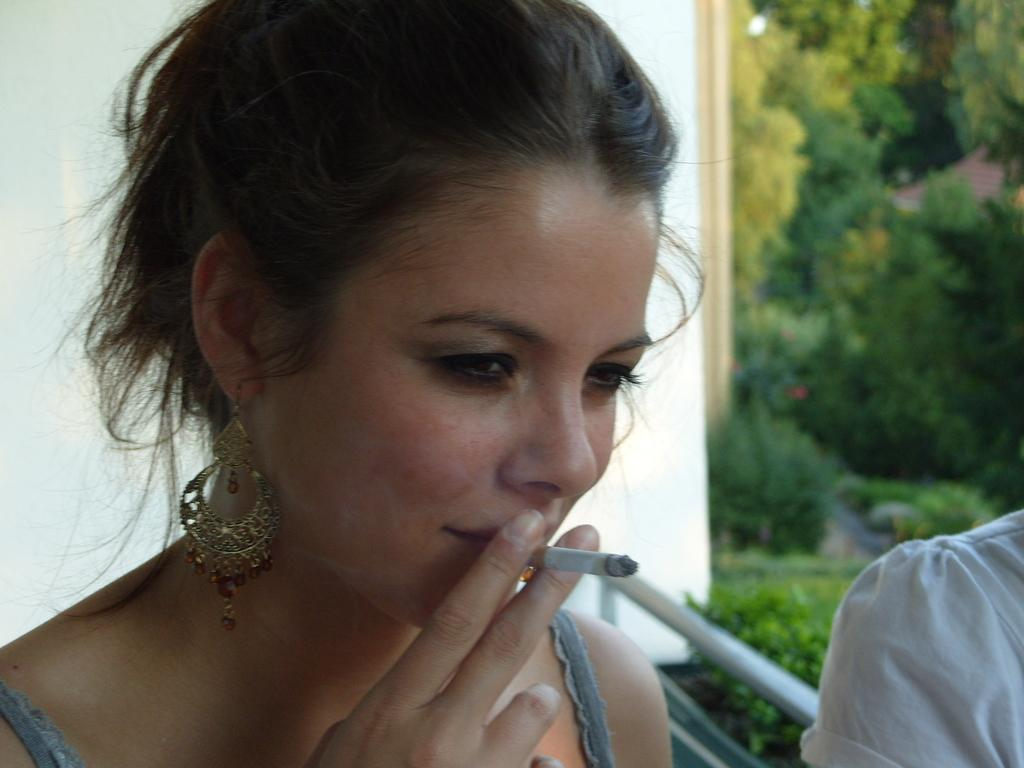Who is present in the image? There is a lady in the image. What is the lady doing in the image? The lady is smoking a cigarette. What can be seen in the background of the image? There is a wall and trees in the background of the image. Can you describe the person on the left side of the image? There is a person on the left side of the image, but no specific details are provided about them. What type of alarm is the lady setting in the image? There is no alarm present in the image; the lady is smoking a cigarette. 